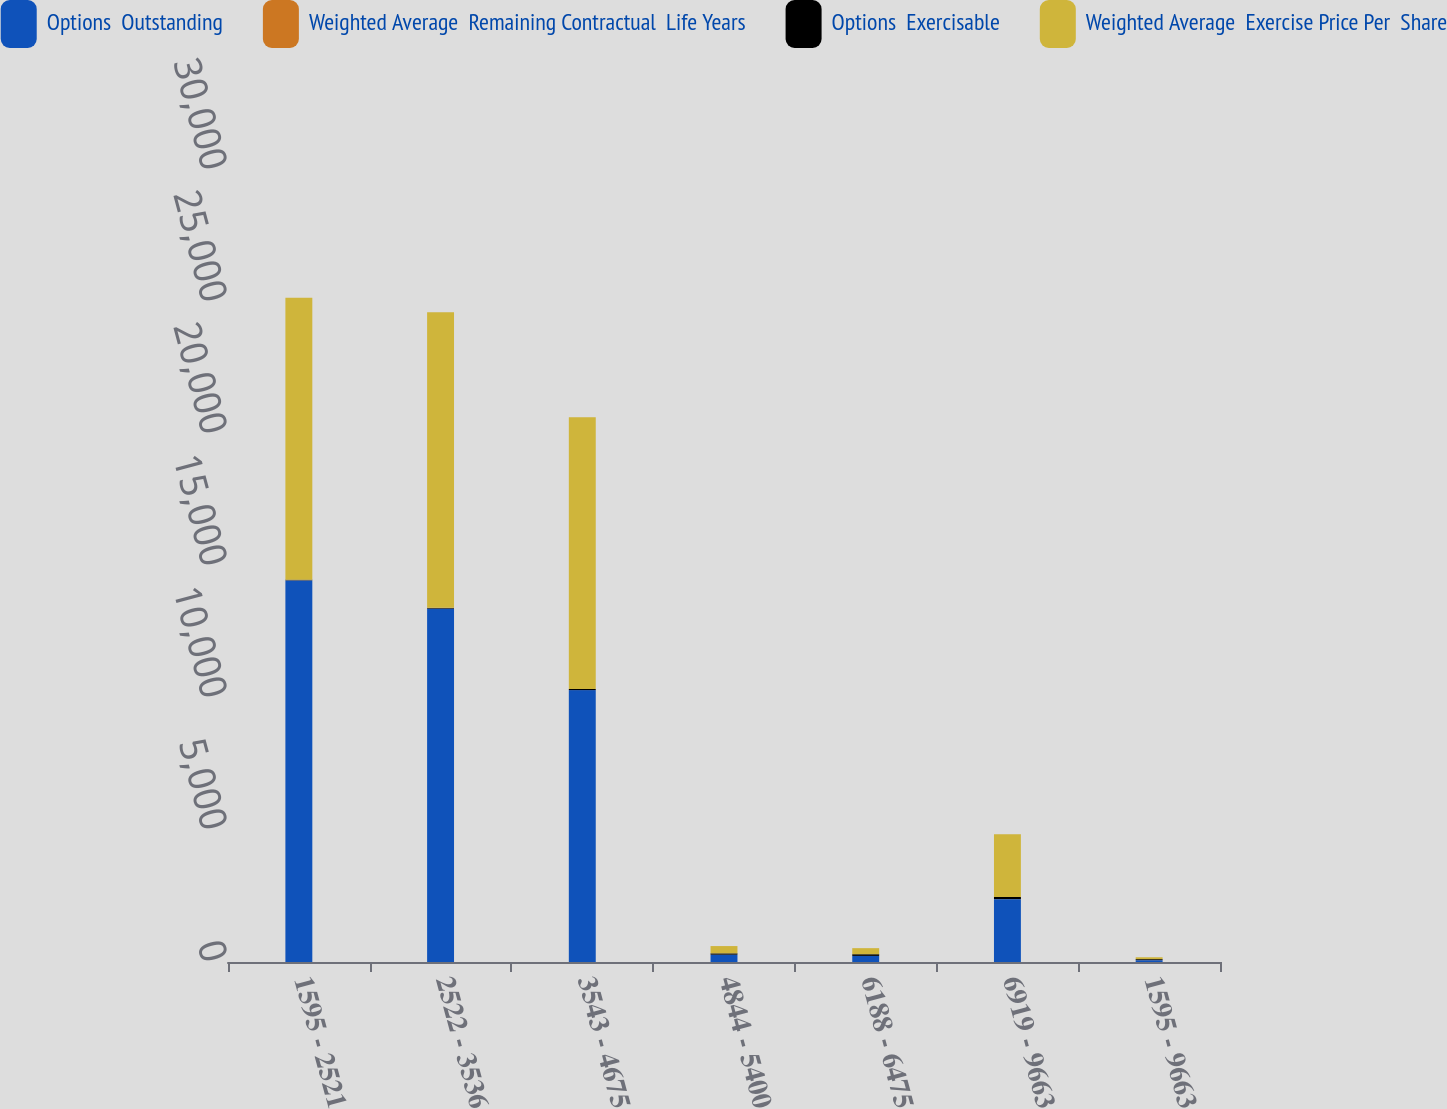<chart> <loc_0><loc_0><loc_500><loc_500><stacked_bar_chart><ecel><fcel>1595 - 2521<fcel>2522 - 3536<fcel>3543 - 4675<fcel>4844 - 5400<fcel>6188 - 6475<fcel>6919 - 9663<fcel>1595 - 9663<nl><fcel>Options  Outstanding<fcel>14454<fcel>13381<fcel>10299<fcel>276<fcel>230<fcel>2381<fcel>71.33<nl><fcel>Weighted Average  Remaining Contractual  Life Years<fcel>4.75<fcel>5.01<fcel>3.53<fcel>1.58<fcel>1.02<fcel>1.16<fcel>4.28<nl><fcel>Options  Exercisable<fcel>22.59<fcel>28.39<fcel>39.82<fcel>50.04<fcel>63.53<fcel>79.13<fcel>32.51<nl><fcel>Weighted Average  Exercise Price Per  Share<fcel>10681<fcel>11196<fcel>10295<fcel>276<fcel>230<fcel>2381<fcel>71.33<nl></chart> 